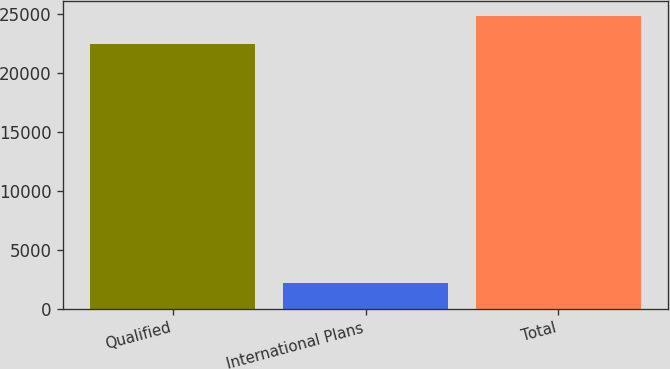Convert chart. <chart><loc_0><loc_0><loc_500><loc_500><bar_chart><fcel>Qualified<fcel>International Plans<fcel>Total<nl><fcel>22413<fcel>2167<fcel>24820<nl></chart> 